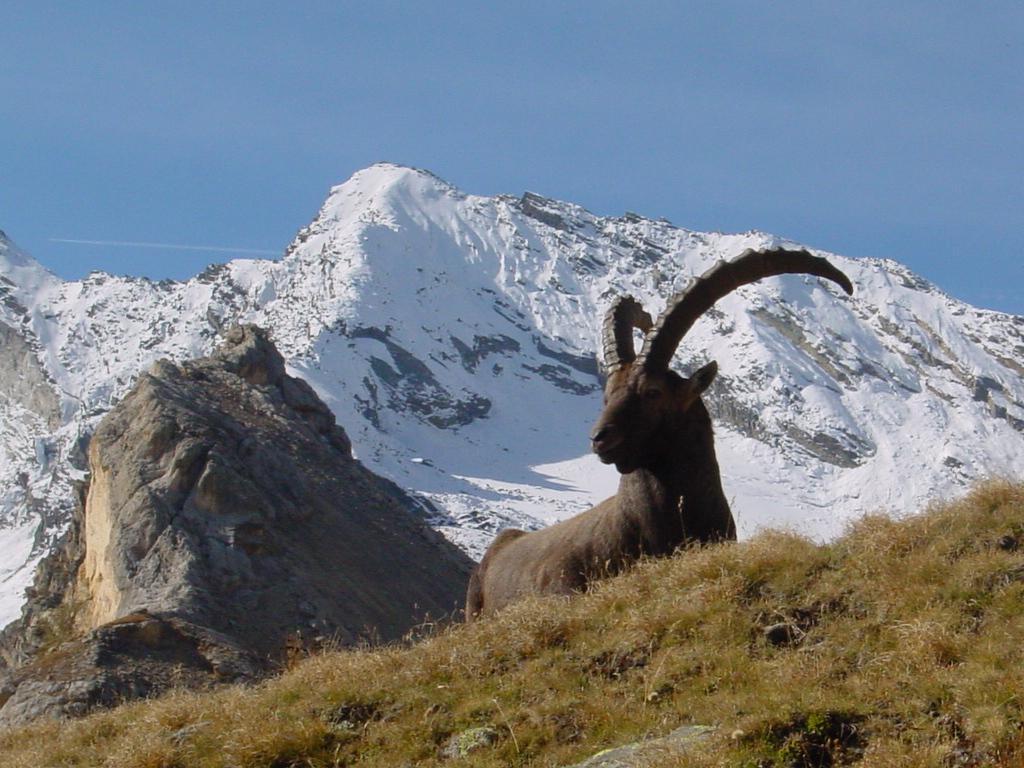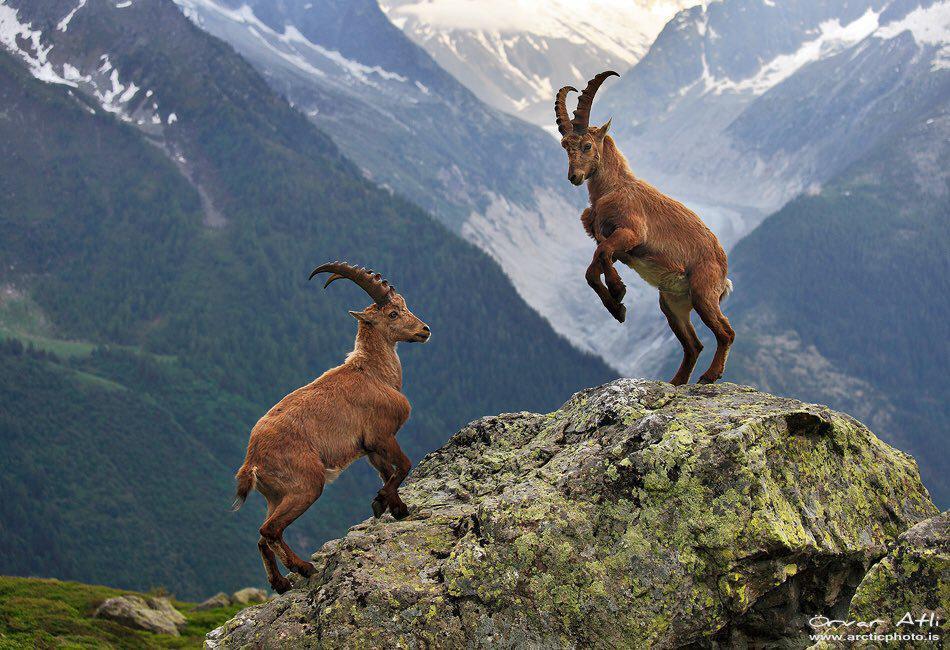The first image is the image on the left, the second image is the image on the right. Given the left and right images, does the statement "At least one of the animals is standing on a boulder in one of the images." hold true? Answer yes or no. Yes. The first image is the image on the left, the second image is the image on the right. For the images shown, is this caption "An image shows multiple horned animals standing atop a rocky peak." true? Answer yes or no. Yes. The first image is the image on the left, the second image is the image on the right. Analyze the images presented: Is the assertion "An image shows no more than two goats standing on a rock peak." valid? Answer yes or no. Yes. The first image is the image on the left, the second image is the image on the right. Analyze the images presented: Is the assertion "There is only one antelope in one of the images" valid? Answer yes or no. Yes. 